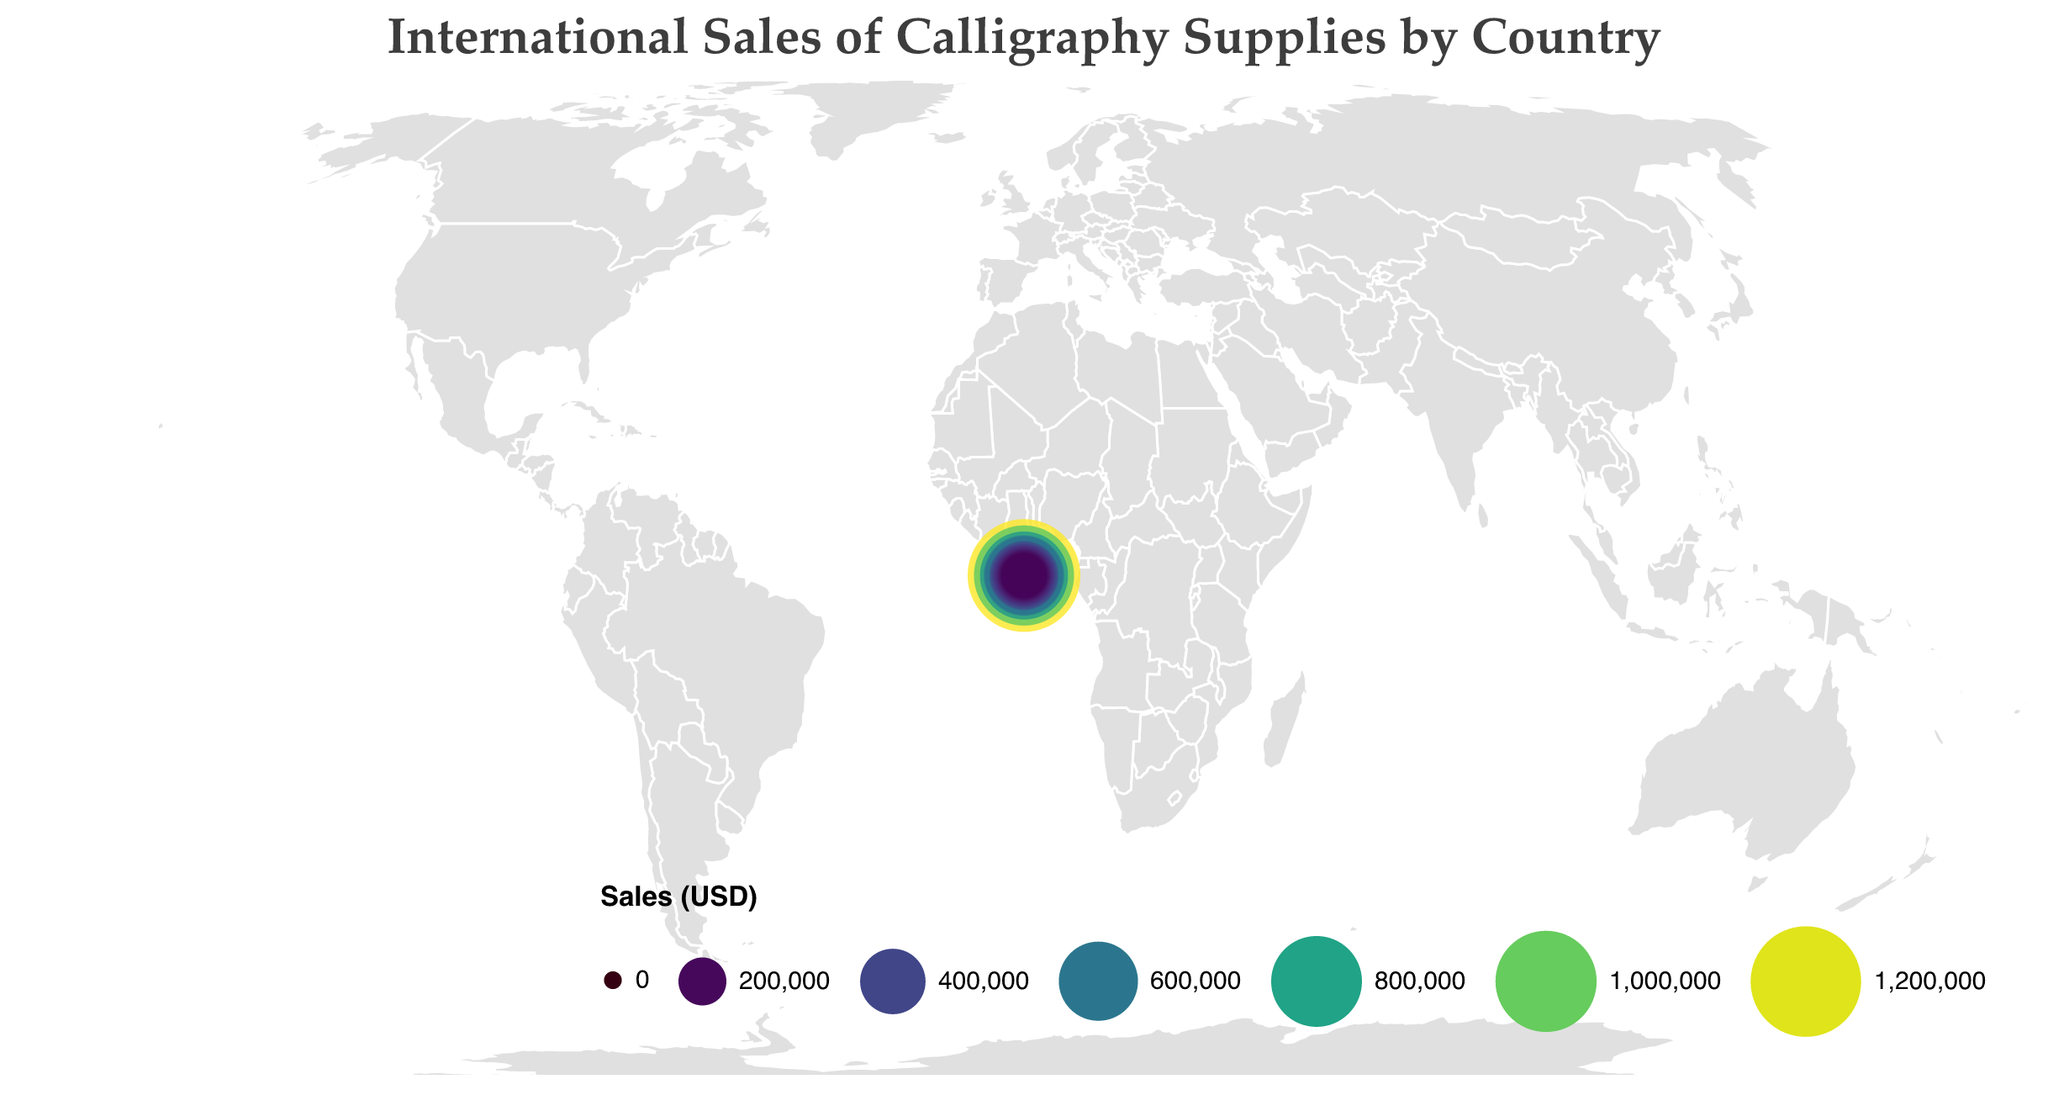What's the highest sales value shown on the map? The highest sales value is found by looking for the largest circle and highest color intensity. The tooltip reveals that the highest value is for China with $1,250,000 in sales.
Answer: $1,250,000 Which country has the second highest sales in calligraphy supplies? The second largest circle and second highest color intensity on the map corresponds to Japan, as indicated by the tooltip showing $980,000 in sales.
Answer: Japan How much is the total sales amount of calligraphy supplies for the United Kingdom and Germany combined? Add the sales for the United Kingdom ($620,000) and Germany ($580,000). $620,000 + $580,000 = $1,200,000
Answer: $1,200,000 Which continent seems to have the most countries with significant sales of calligraphy supplies? By observing the geographic distribution of circles, it appears that Asia has the most countries with significant sales (e.g., China, Japan, South Korea, India).
Answer: Asia Are sales higher in France or in South Korea? Compare the sizes and color intensity of the circles for France and South Korea. The tooltip indicates France has $450,000 in sales and South Korea has $380,000 in sales.
Answer: France What's the difference in sales between Italy and Canada? Subtract the sales of Canada ($350,000) from Italy ($420,000). $420,000 - $350,000 = $70,000
Answer: $70,000 How do the sales in the United States compare to those in Canada? Compare the size and color of the circles; the tooltip shows the United States has $750,000 in sales and Canada has $350,000.
Answer: United States has higher sales than Canada What is the average sales value among all countries listed? Calculate the sum of all sales values and divide by the number of countries. The sum is $1250000 (China) + $980000 (Japan) + $750000 (United States) + $620000 (United Kingdom) + $580000 (Germany) + $450000 (France) + $420000 (Italy) + $380000 (South Korea) + $350000 (Canada) + $320000 (Australia) + $290000 (Spain) + $260000 (Netherlands) + $230000 (India) + $210000 (Russia) + $180000 (Brazil) = $7920000. There are 15 countries, so average is $7920000 / 15 = $528,000.
Answer: $528,000 Which country in South America has the highest sales? Observe the geographic location of South America; the tooltip shows that Brazil has $180,000 in sales, the highest in that region.
Answer: Brazil 